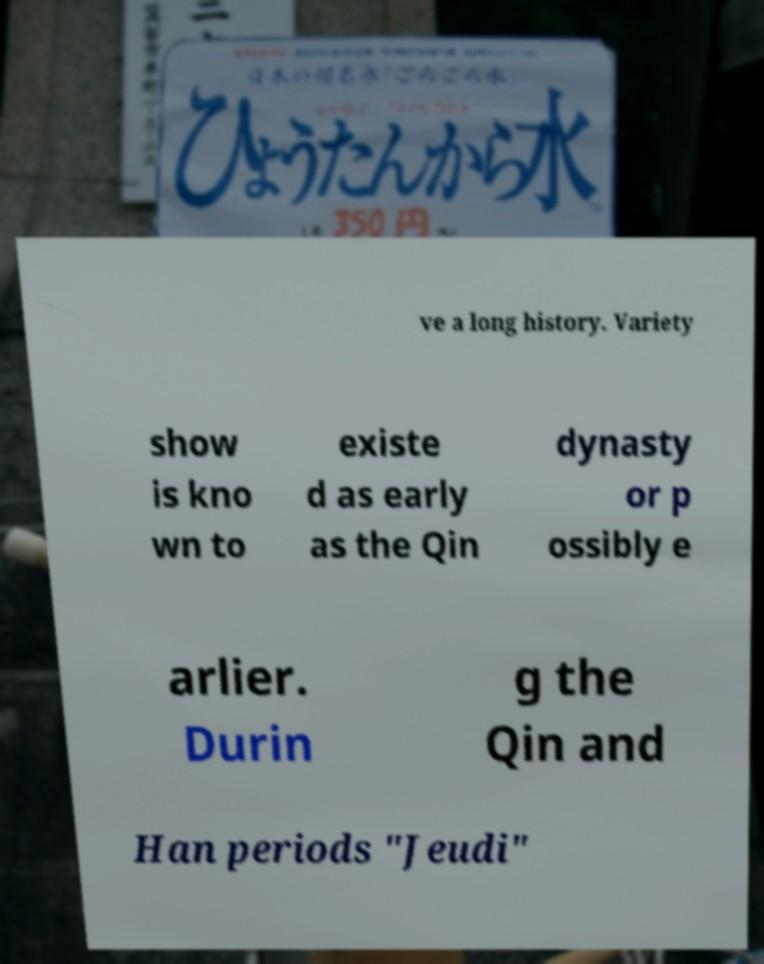Can you read and provide the text displayed in the image?This photo seems to have some interesting text. Can you extract and type it out for me? ve a long history. Variety show is kno wn to existe d as early as the Qin dynasty or p ossibly e arlier. Durin g the Qin and Han periods "Jeudi" 